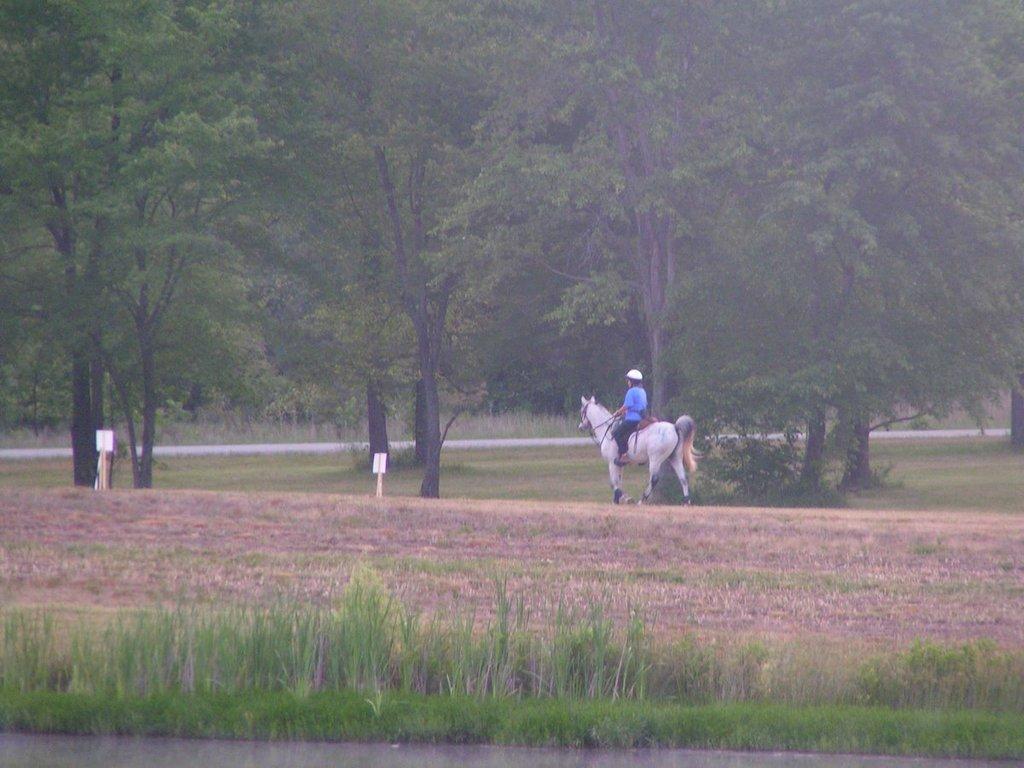Could you give a brief overview of what you see in this image? In the foreground I can see grass and a person is riding a horse on the ground. In the background I can see boards and trees. This image is taken may be during a day. 